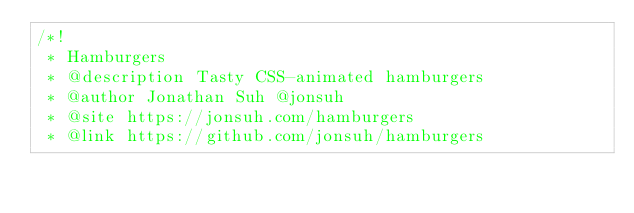<code> <loc_0><loc_0><loc_500><loc_500><_CSS_>/*!
 * Hamburgers
 * @description Tasty CSS-animated hamburgers
 * @author Jonathan Suh @jonsuh
 * @site https://jonsuh.com/hamburgers
 * @link https://github.com/jonsuh/hamburgers</code> 